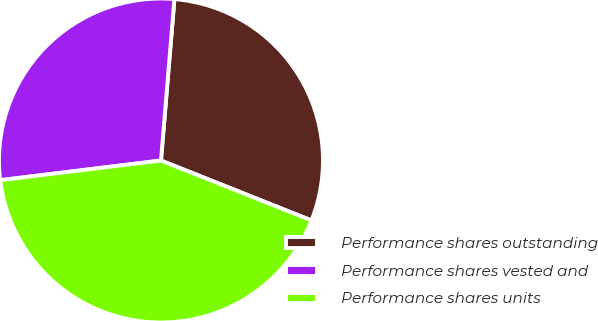<chart> <loc_0><loc_0><loc_500><loc_500><pie_chart><fcel>Performance shares outstanding<fcel>Performance shares vested and<fcel>Performance shares units<nl><fcel>29.71%<fcel>28.26%<fcel>42.03%<nl></chart> 